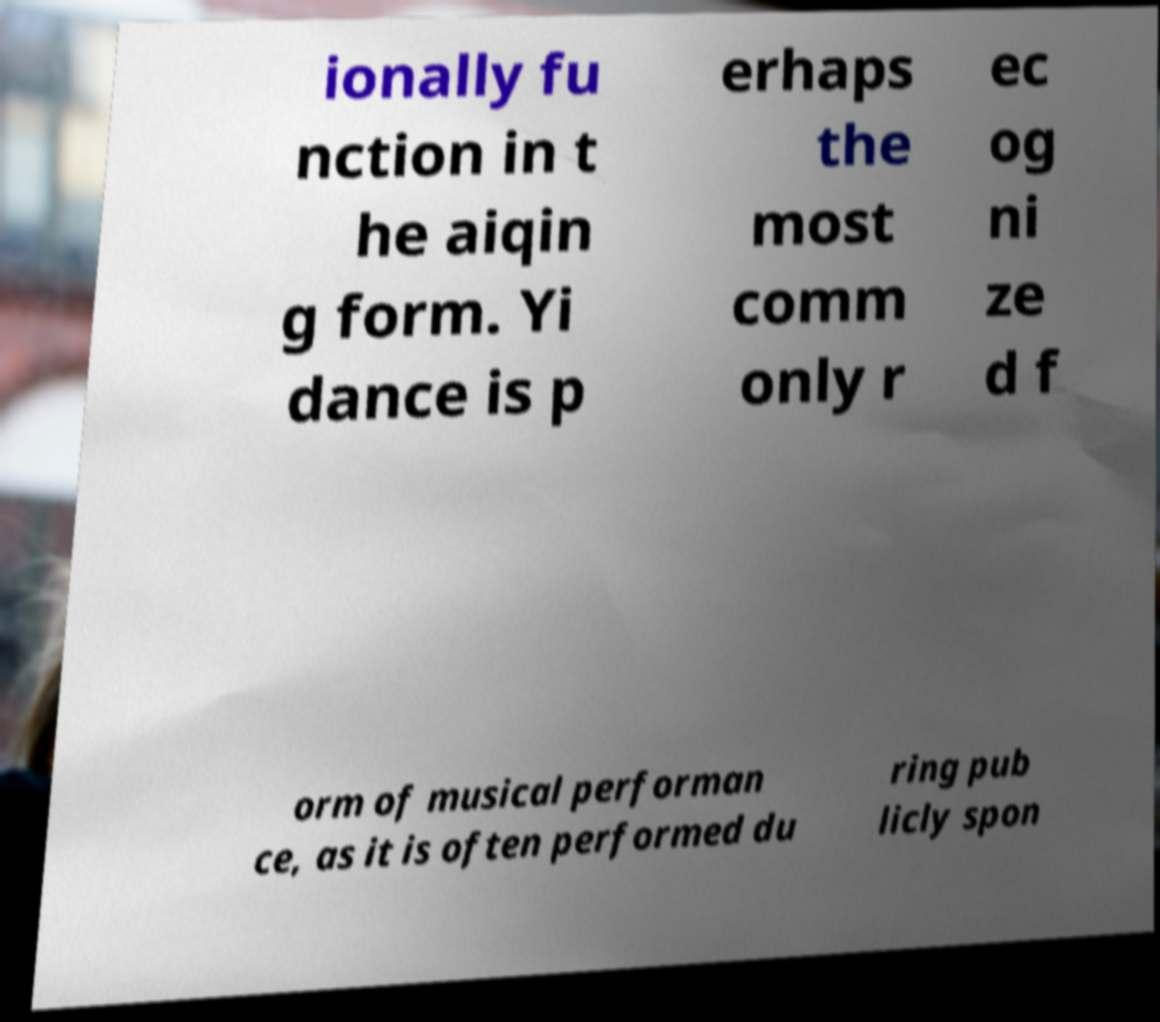There's text embedded in this image that I need extracted. Can you transcribe it verbatim? ionally fu nction in t he aiqin g form. Yi dance is p erhaps the most comm only r ec og ni ze d f orm of musical performan ce, as it is often performed du ring pub licly spon 